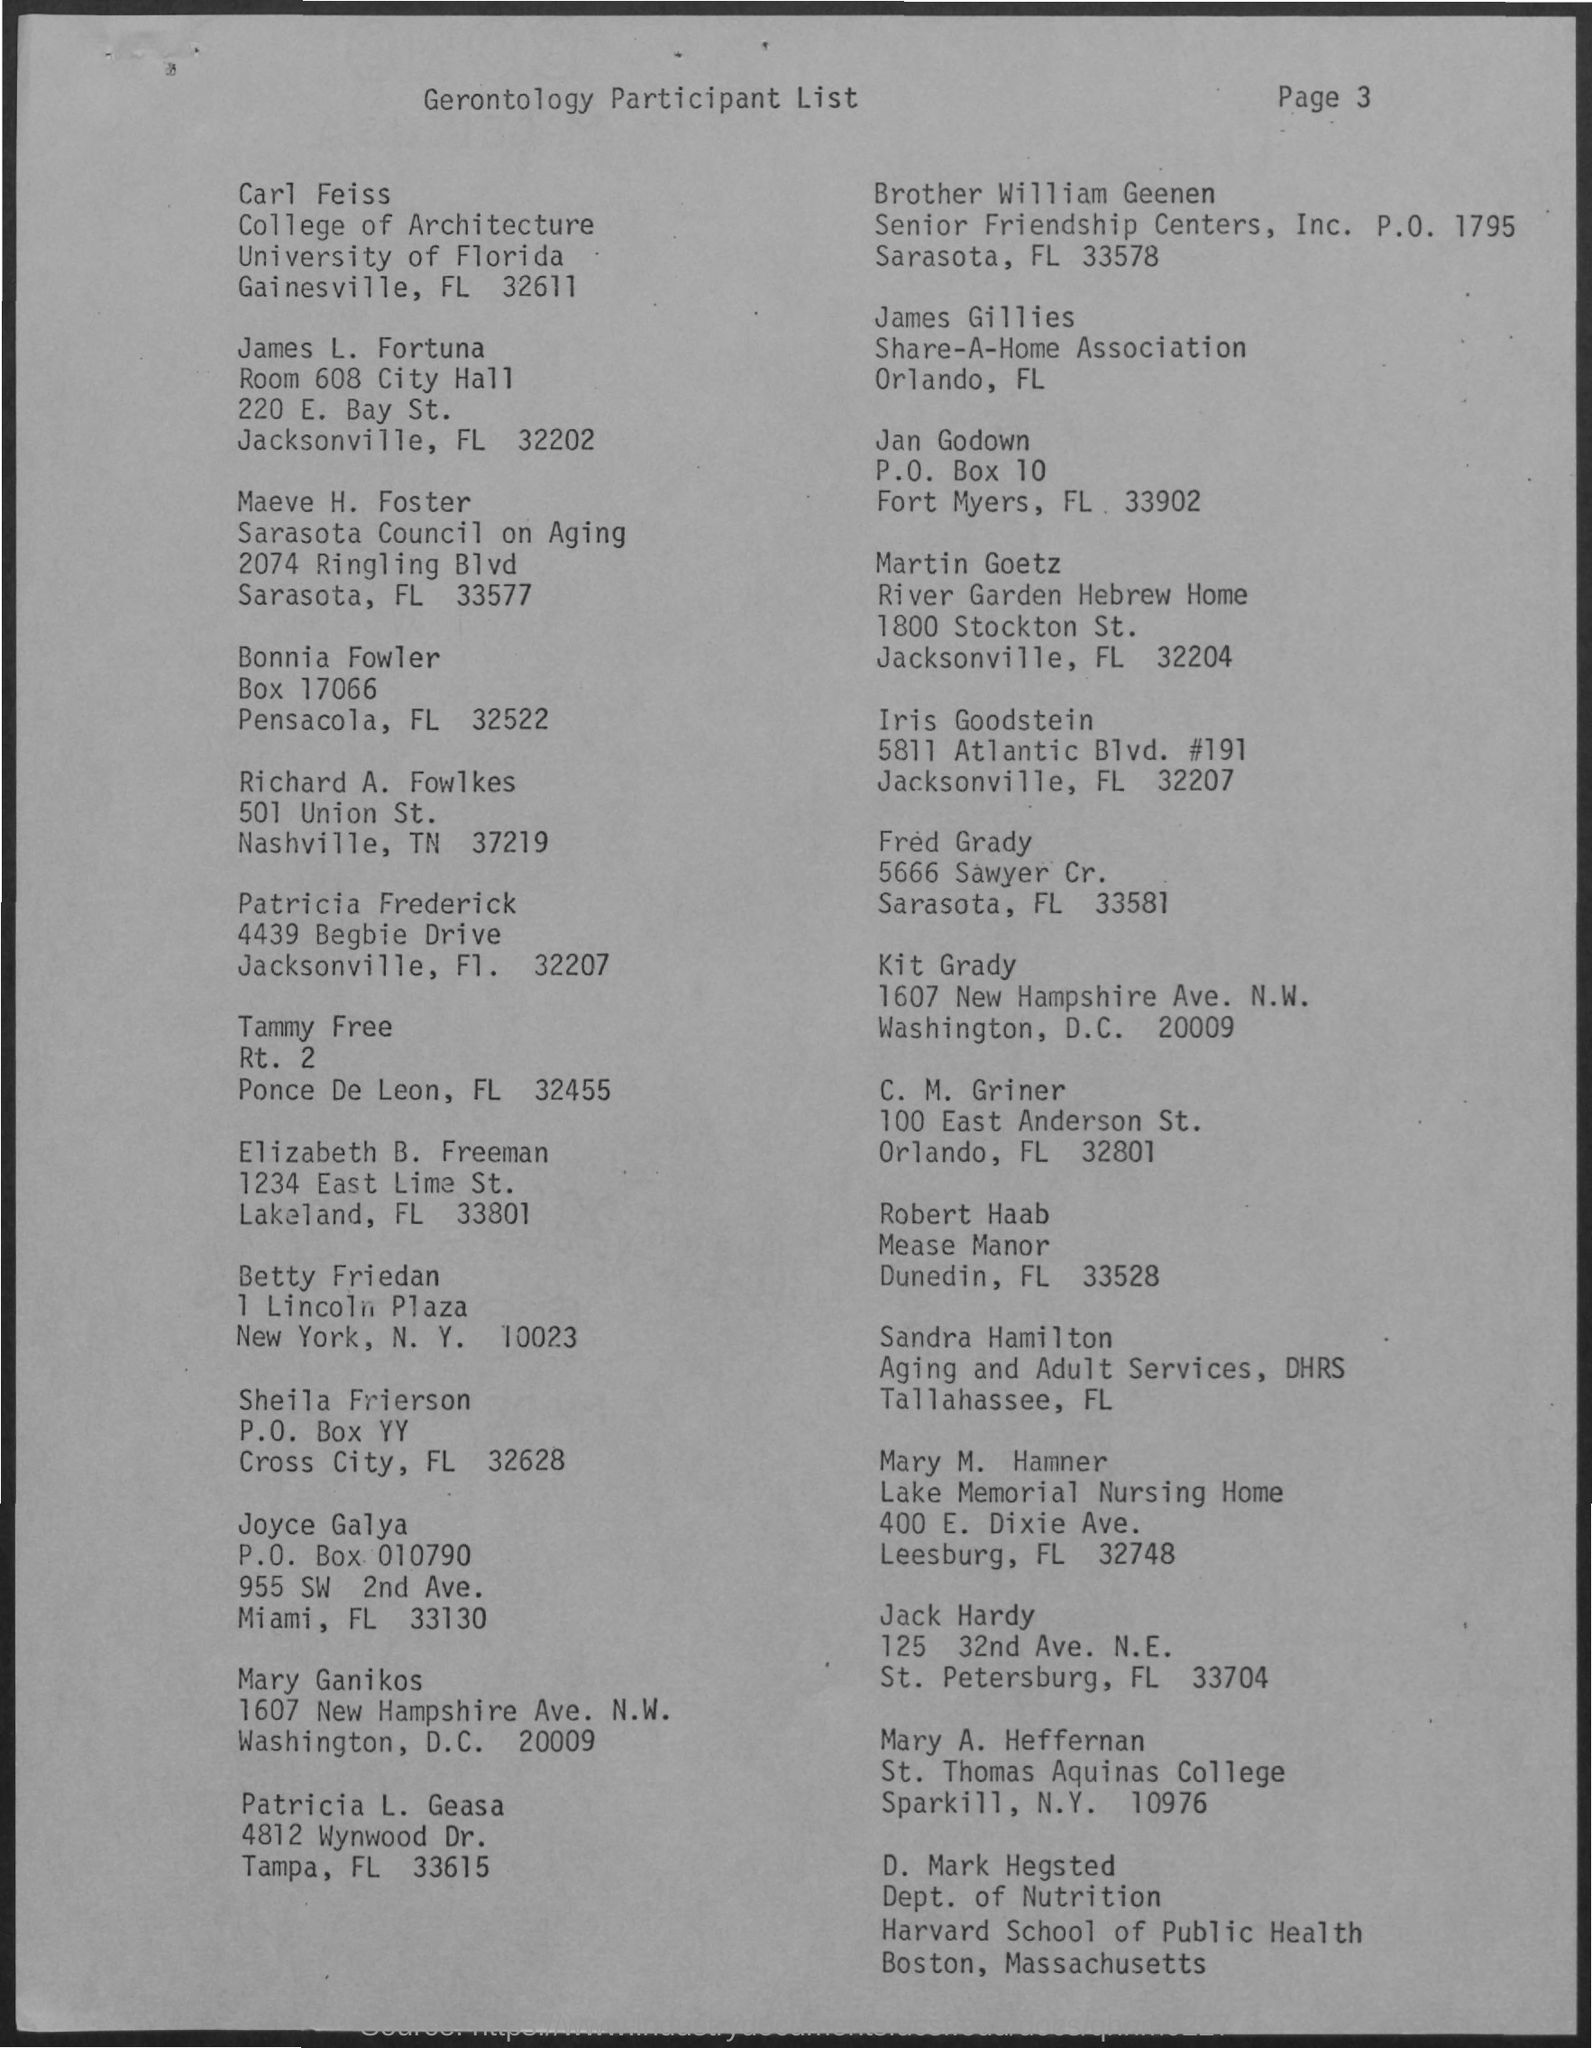Indicate a few pertinent items in this graphic. Carl Feiss is a student at the University of Florida. 